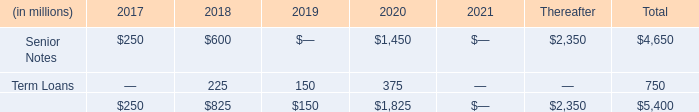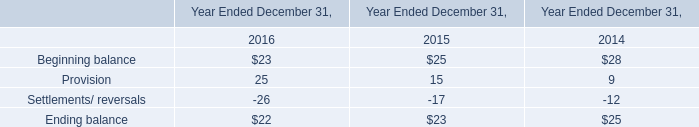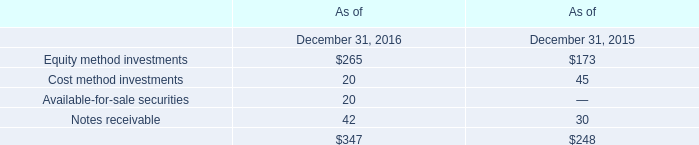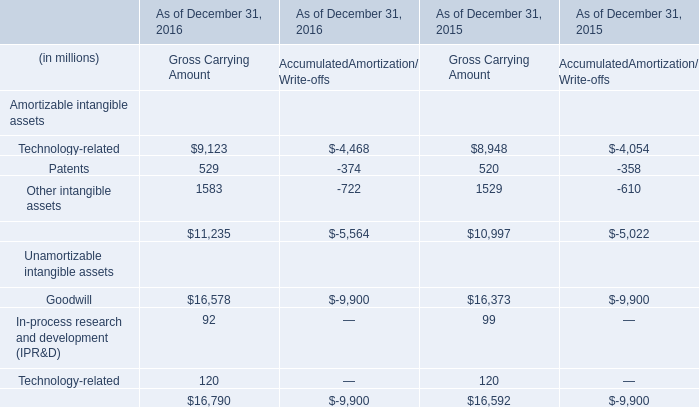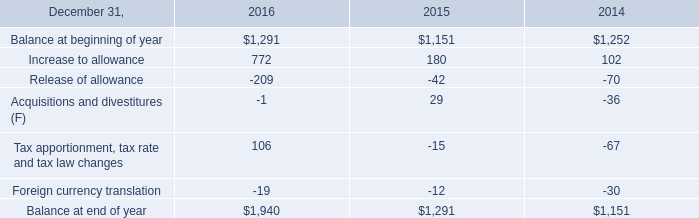In the year with largest amount of Equity method investments, what's the increasing rate of Notes receivable? 
Computations: ((42 - 30) / 30)
Answer: 0.4. 